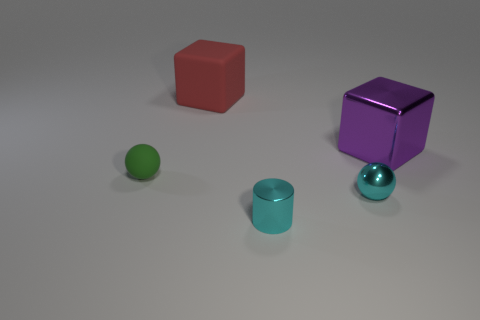What material is the small cylinder that is the same color as the tiny metallic sphere?
Provide a short and direct response. Metal. What is the shape of the object that is the same color as the metal ball?
Offer a very short reply. Cylinder. Does the cube on the right side of the large red thing have the same material as the cyan sphere?
Your answer should be compact. Yes. Are there any other things that are the same material as the red block?
Offer a terse response. Yes. The metallic cylinder that is the same size as the cyan shiny sphere is what color?
Offer a terse response. Cyan. Are there any small cylinders of the same color as the rubber ball?
Provide a succinct answer. No. What is the size of the sphere that is made of the same material as the red object?
Your answer should be compact. Small. What size is the shiny sphere that is the same color as the cylinder?
Your answer should be very brief. Small. How many other objects are the same size as the shiny sphere?
Provide a succinct answer. 2. What material is the large thing that is to the left of the tiny cyan ball?
Provide a succinct answer. Rubber. 